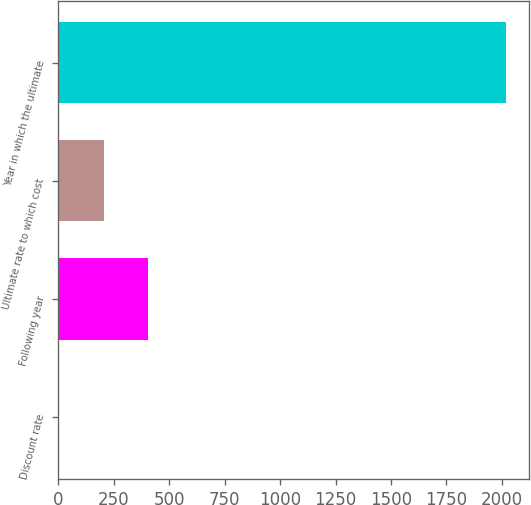Convert chart. <chart><loc_0><loc_0><loc_500><loc_500><bar_chart><fcel>Discount rate<fcel>Following year<fcel>Ultimate rate to which cost<fcel>Year in which the ultimate<nl><fcel>3.7<fcel>406.96<fcel>205.33<fcel>2020<nl></chart> 